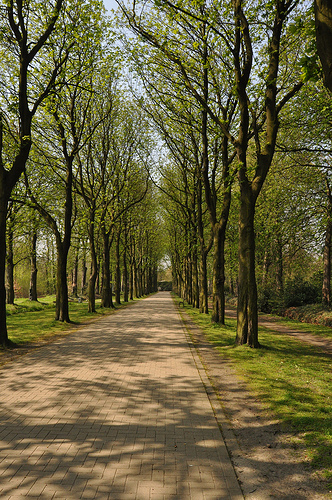<image>
Can you confirm if the tree is above the grass? No. The tree is not positioned above the grass. The vertical arrangement shows a different relationship. 